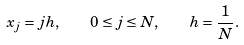<formula> <loc_0><loc_0><loc_500><loc_500>x _ { j } = j h , \quad 0 \leq j \leq N , \quad h = \frac { 1 } { N } .</formula> 